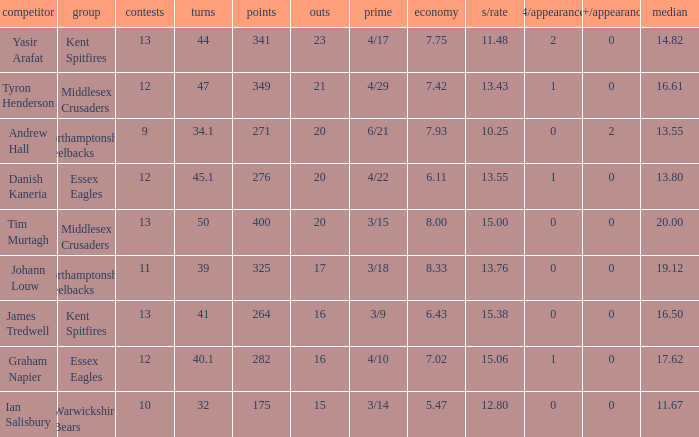Name the least matches for runs being 276 12.0. 